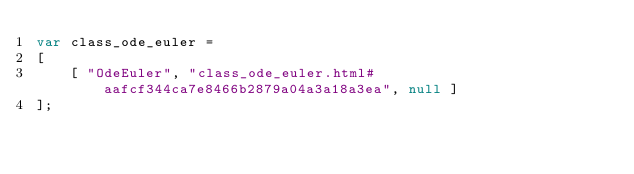<code> <loc_0><loc_0><loc_500><loc_500><_JavaScript_>var class_ode_euler =
[
    [ "OdeEuler", "class_ode_euler.html#aafcf344ca7e8466b2879a04a3a18a3ea", null ]
];</code> 